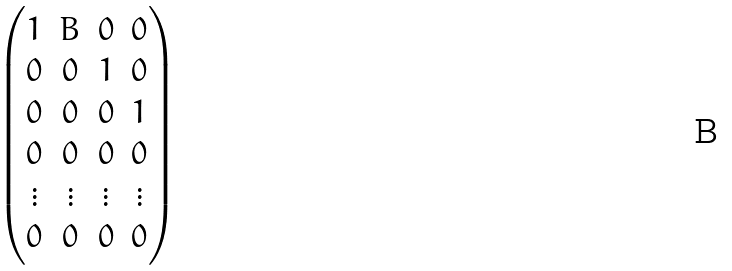<formula> <loc_0><loc_0><loc_500><loc_500>\begin{pmatrix} 1 & B & 0 & 0 \\ 0 & 0 & 1 & 0 \\ 0 & 0 & 0 & 1 \\ 0 & 0 & 0 & 0 \\ \vdots & \vdots & \vdots & \vdots \\ 0 & 0 & 0 & 0 \\ \end{pmatrix}</formula> 